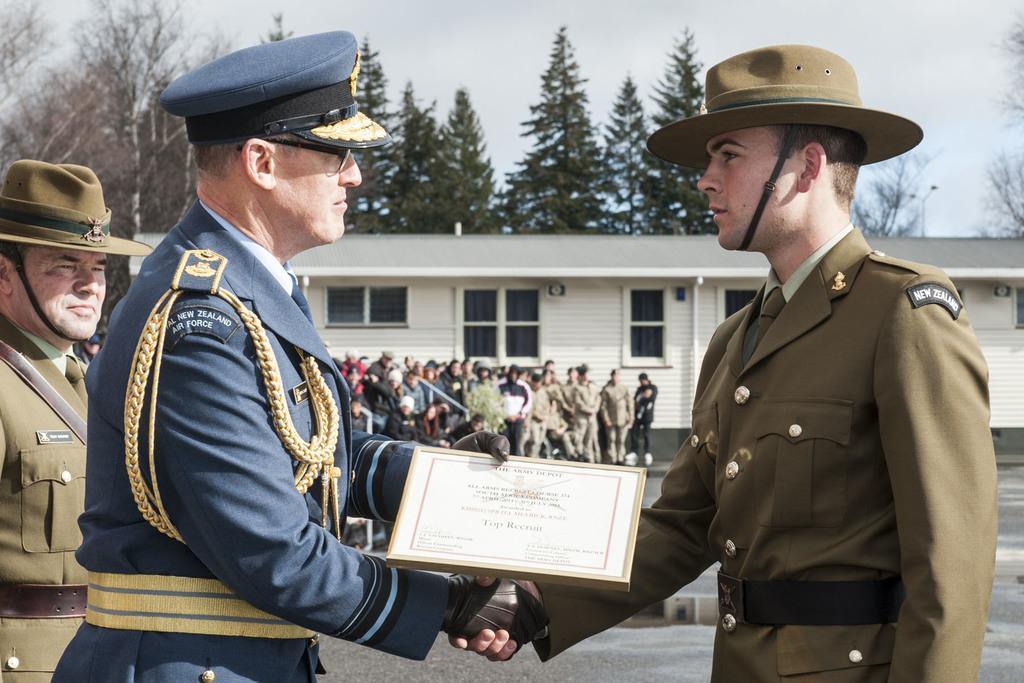Can you describe this image briefly? In the image in the center we can see two persons are standing and they are wearing cap. And one person holding frame. On the left side of the image,we can see one person standing and wearing cap. In the background we can see the sky,clouds,trees,buildings,windows and group of people are standing. 